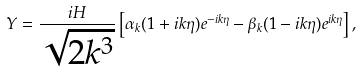<formula> <loc_0><loc_0><loc_500><loc_500>Y = \frac { i H } { \sqrt { 2 k ^ { 3 } } } \left [ \alpha _ { k } ( 1 + i k \eta ) e ^ { - i k \eta } - \beta _ { k } ( 1 - i k \eta ) e ^ { i k \eta } \right ] ,</formula> 